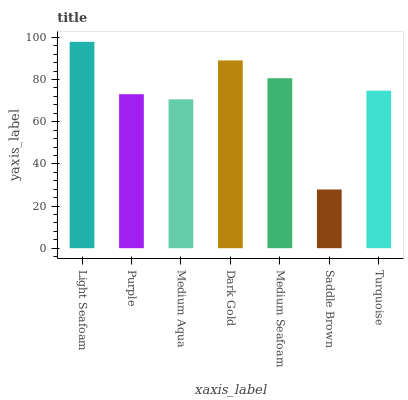Is Purple the minimum?
Answer yes or no. No. Is Purple the maximum?
Answer yes or no. No. Is Light Seafoam greater than Purple?
Answer yes or no. Yes. Is Purple less than Light Seafoam?
Answer yes or no. Yes. Is Purple greater than Light Seafoam?
Answer yes or no. No. Is Light Seafoam less than Purple?
Answer yes or no. No. Is Turquoise the high median?
Answer yes or no. Yes. Is Turquoise the low median?
Answer yes or no. Yes. Is Dark Gold the high median?
Answer yes or no. No. Is Medium Seafoam the low median?
Answer yes or no. No. 